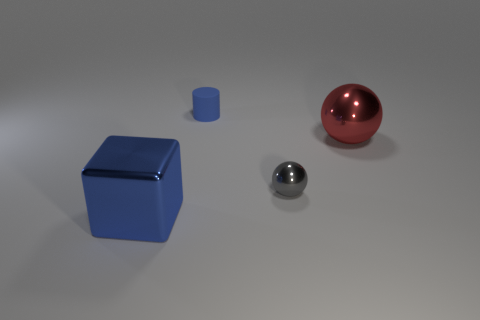Add 4 big blue objects. How many big blue objects are left? 5 Add 1 large yellow matte cubes. How many large yellow matte cubes exist? 1 Add 4 large gray cylinders. How many objects exist? 8 Subtract all gray spheres. How many spheres are left? 1 Subtract 0 blue spheres. How many objects are left? 4 Subtract all purple balls. Subtract all blue blocks. How many balls are left? 2 Subtract all blue cubes. How many red balls are left? 1 Subtract all big purple rubber things. Subtract all blue things. How many objects are left? 2 